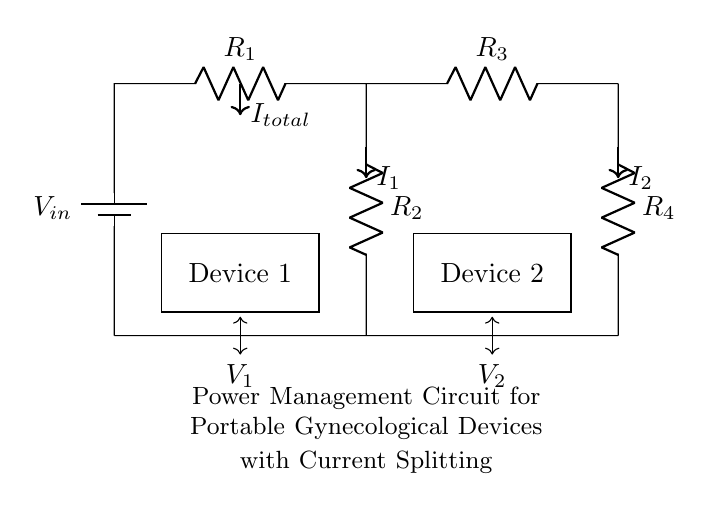What is the total current represented in the circuit? The total current is represented by the arrow labeled \(I_{total}\), which indicates the combined current flowing through the circuit from the battery.
Answer: I total What are the resistances used in this circuit? The circuit diagram lists four resistors: \(R_1\), \(R_2\), \(R_3\), and \(R_4\). These are labeled next to their respective positions in the circuit.
Answer: R1, R2, R3, R4 What type of circuit configuration is being used here? The circuit is a current divider, as evidenced by the way the current splits between multiple resistors (devices) connected in parallel after the initial resistor.
Answer: Current divider What is the voltage across Device 1? The voltage across Device 1 is indicated by the label \(V_1\) in the circuit, marked beneath the device. This signifies the potential difference over that particular component.
Answer: V1 How many devices are powered by this circuit? The circuit diagram shows two devices, which are labeled as Device 1 and Device 2, both receiving power from the splitting current.
Answer: Two What happens to the current flowing through each resistor? In a current divider, the total current divides among the parallel resistors based on their resistances. This means that the current flowing through each resistor (displayed as \(I_1\) and \(I_2\)) is a fraction of the total current depending on their resistance values.
Answer: Divides based on resistance How is the total voltage supplied to the circuit? The total voltage is supplied by the battery labeled \(V_{in}\) at the top of the circuit, providing the energy necessary for the entire circuit operation.
Answer: V in 